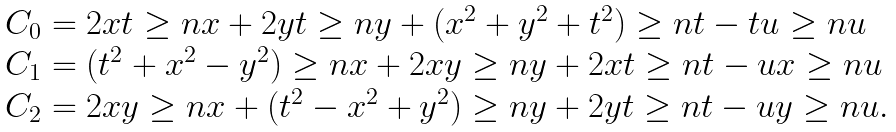<formula> <loc_0><loc_0><loc_500><loc_500>\begin{array} { l l l } & C _ { 0 } = 2 x t \geq n x + 2 y t \geq n y + ( x ^ { 2 } + y ^ { 2 } + t ^ { 2 } ) \geq n t - t u \geq n u \\ & C _ { 1 } = ( t ^ { 2 } + x ^ { 2 } - y ^ { 2 } ) \geq n x + 2 x y \geq n y + 2 x t \geq n t - u x \geq n u \\ & C _ { 2 } = 2 x y \geq n x + ( t ^ { 2 } - x ^ { 2 } + y ^ { 2 } ) \geq n y + 2 y t \geq n t - u y \geq n u . \end{array}</formula> 